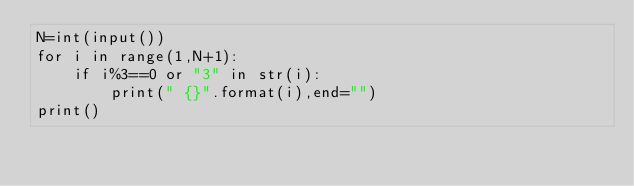Convert code to text. <code><loc_0><loc_0><loc_500><loc_500><_Python_>N=int(input())
for i in range(1,N+1):
    if i%3==0 or "3" in str(i):
        print(" {}".format(i),end="")
print()
</code> 